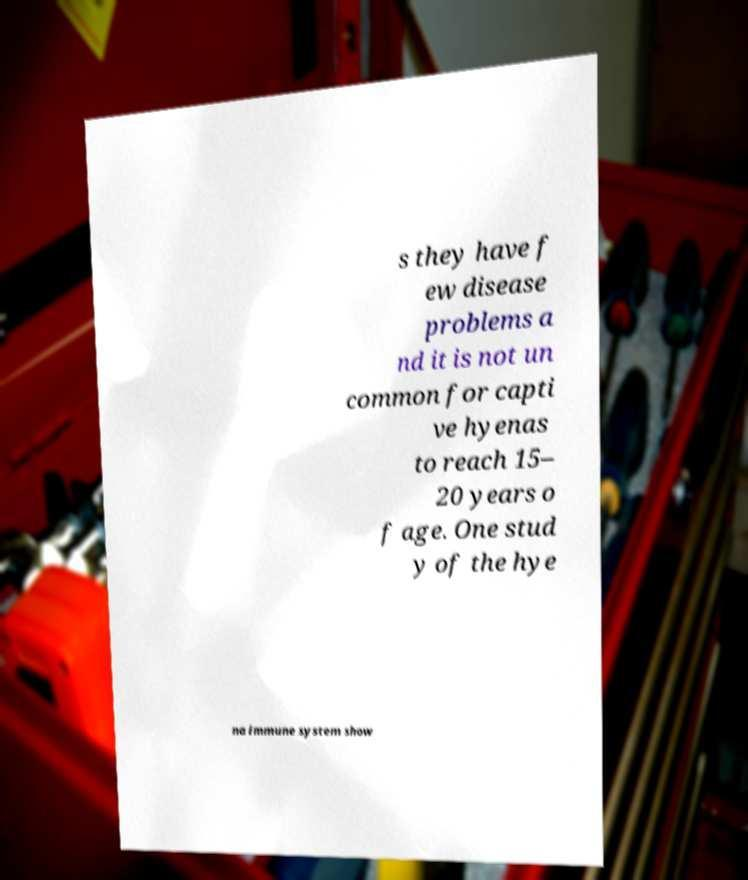Could you extract and type out the text from this image? s they have f ew disease problems a nd it is not un common for capti ve hyenas to reach 15– 20 years o f age. One stud y of the hye na immune system show 